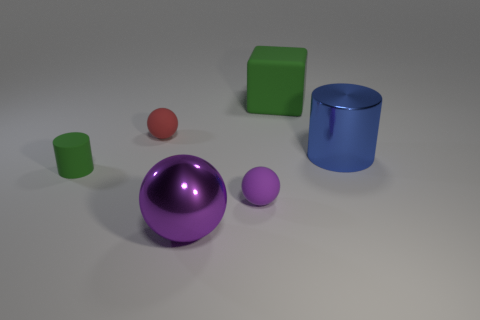Is the color of the large thing left of the rubber cube the same as the metallic thing that is behind the tiny purple thing?
Ensure brevity in your answer.  No. The matte object that is the same color as the big block is what size?
Your response must be concise. Small. How many other objects are the same size as the green cylinder?
Your answer should be very brief. 2. There is a shiny object that is right of the purple rubber sphere; what color is it?
Give a very brief answer. Blue. Is the material of the cylinder to the left of the red rubber sphere the same as the blue object?
Your answer should be compact. No. How many cylinders are on the right side of the small purple thing and left of the red rubber sphere?
Provide a short and direct response. 0. The large thing that is in front of the cylinder right of the shiny object that is to the left of the green rubber block is what color?
Provide a succinct answer. Purple. How many other objects are there of the same shape as the large purple thing?
Make the answer very short. 2. Is there a purple metallic sphere to the right of the green object that is behind the shiny cylinder?
Give a very brief answer. No. How many metal objects are either blocks or small brown cylinders?
Your answer should be very brief. 0. 